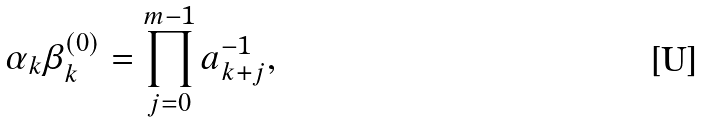Convert formula to latex. <formula><loc_0><loc_0><loc_500><loc_500>\alpha _ { k } \beta _ { k } ^ { ( 0 ) } = \prod _ { j = 0 } ^ { m - 1 } a _ { k + j } ^ { - 1 } ,</formula> 